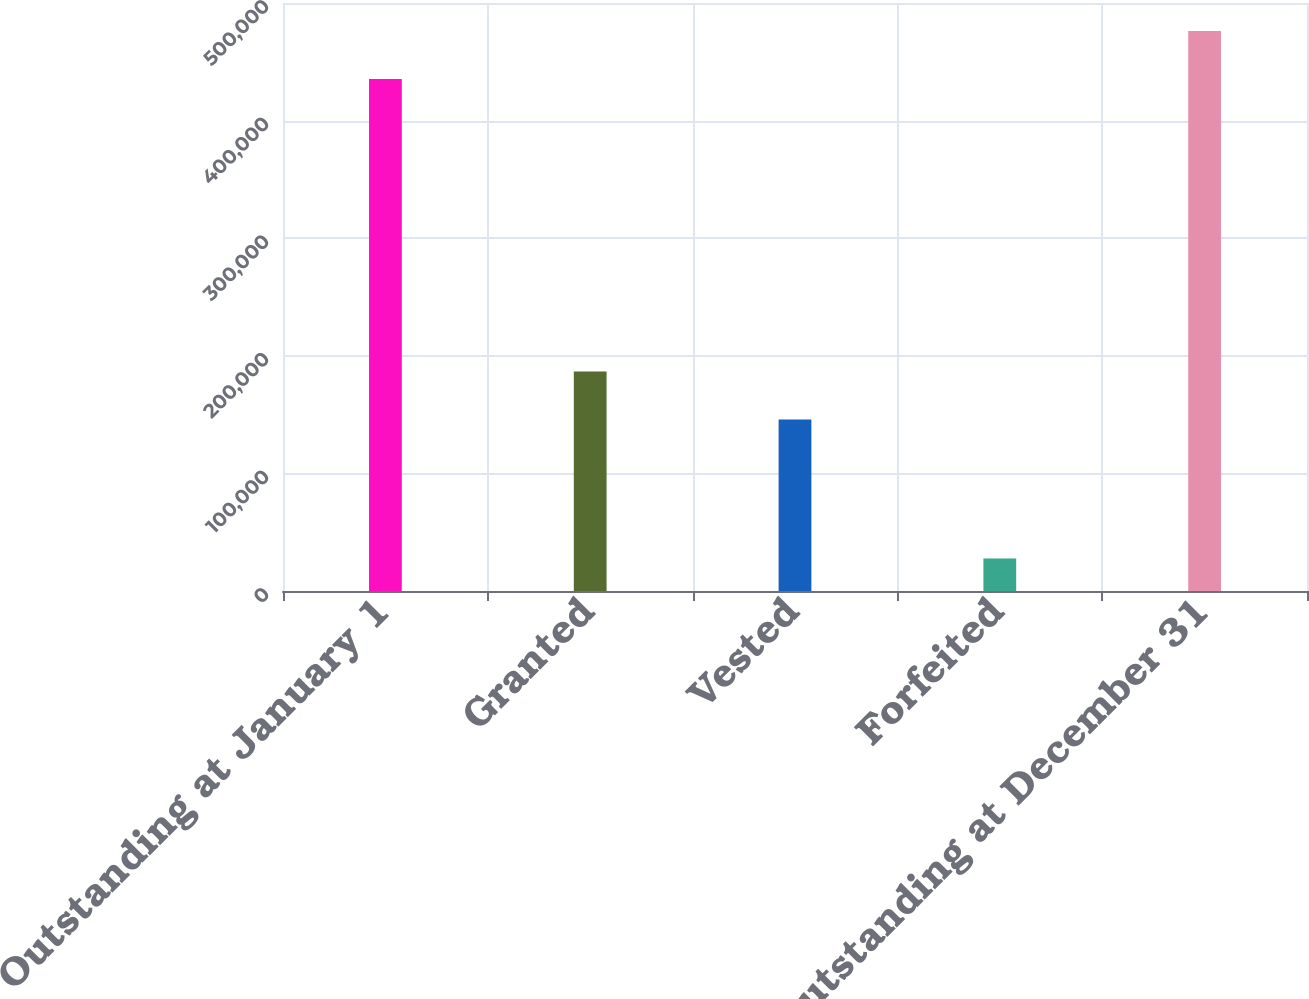Convert chart. <chart><loc_0><loc_0><loc_500><loc_500><bar_chart><fcel>Outstanding at January 1<fcel>Granted<fcel>Vested<fcel>Forfeited<fcel>Outstanding at December 31<nl><fcel>435336<fcel>186597<fcel>145834<fcel>27710<fcel>476099<nl></chart> 